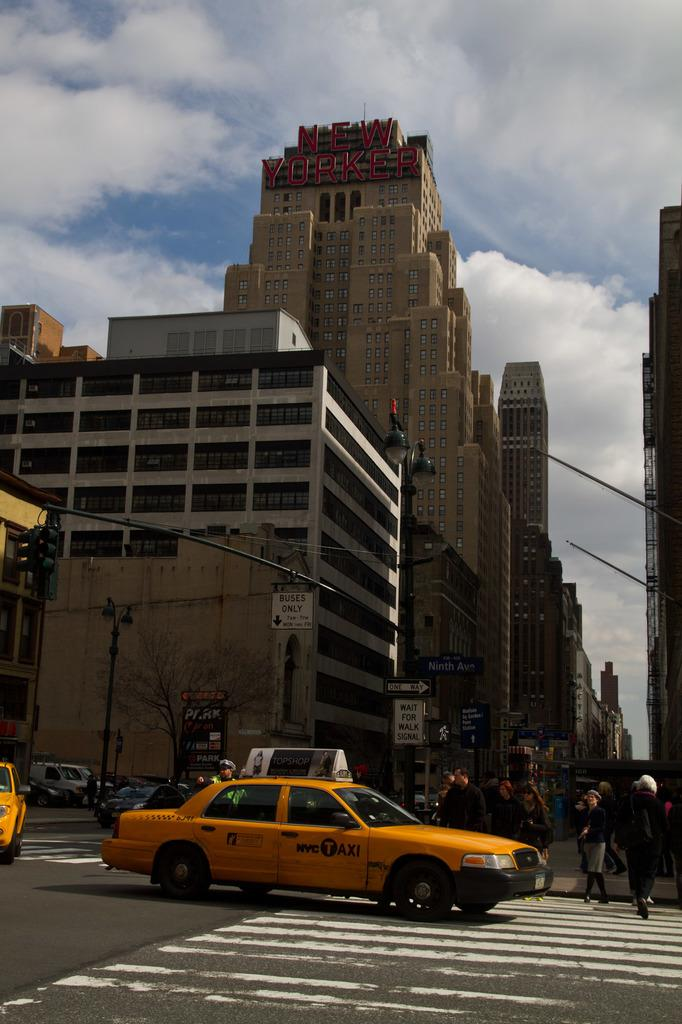Provide a one-sentence caption for the provided image. In a busy city scene, the New Yorker building towers over street traffic going one way. 